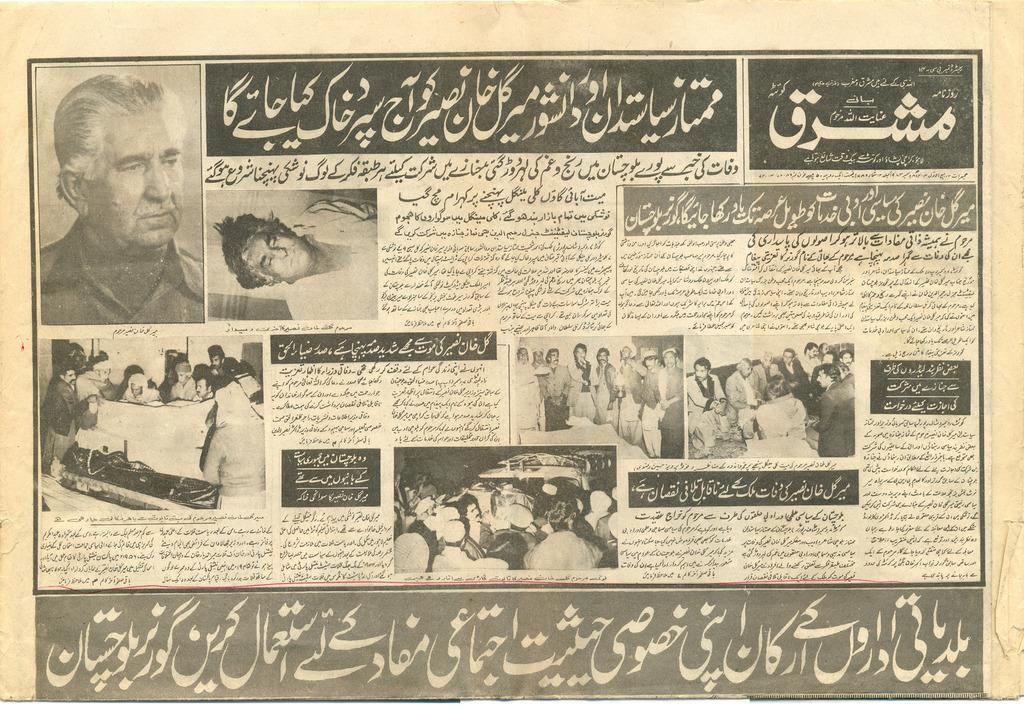What is the main object in the image? There is a newspaper in the image. What can be found within the newspaper? The newspaper contains pictures and text. What do the pictures in the newspaper depict? The pictures on the newspaper depict many people. What type of blood is visible on the egg in the image? There is no blood or egg present in the image; it features a newspaper with pictures and text. 